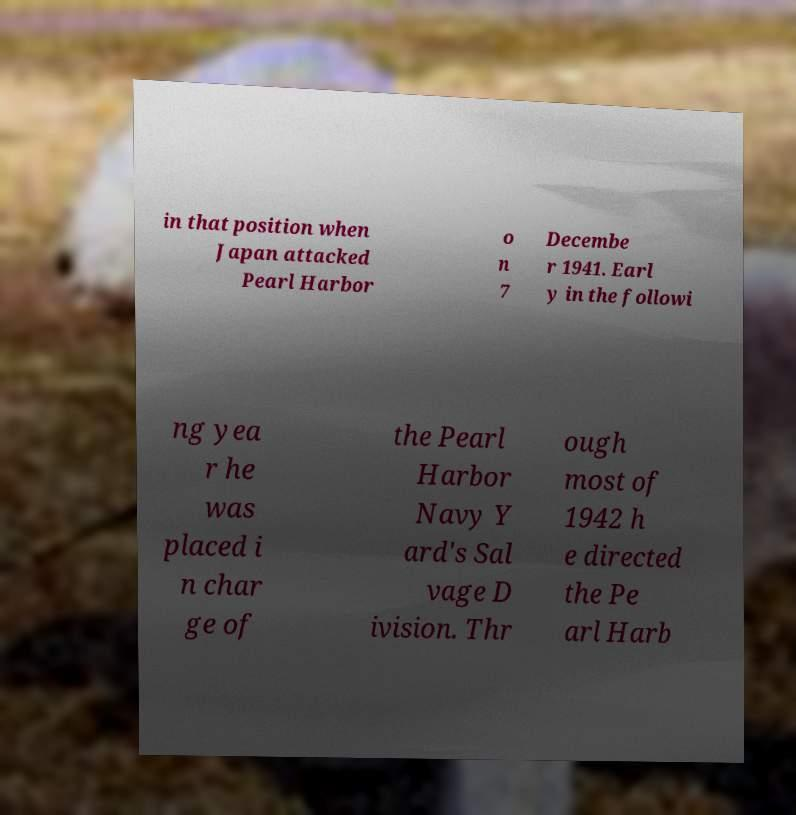For documentation purposes, I need the text within this image transcribed. Could you provide that? in that position when Japan attacked Pearl Harbor o n 7 Decembe r 1941. Earl y in the followi ng yea r he was placed i n char ge of the Pearl Harbor Navy Y ard's Sal vage D ivision. Thr ough most of 1942 h e directed the Pe arl Harb 